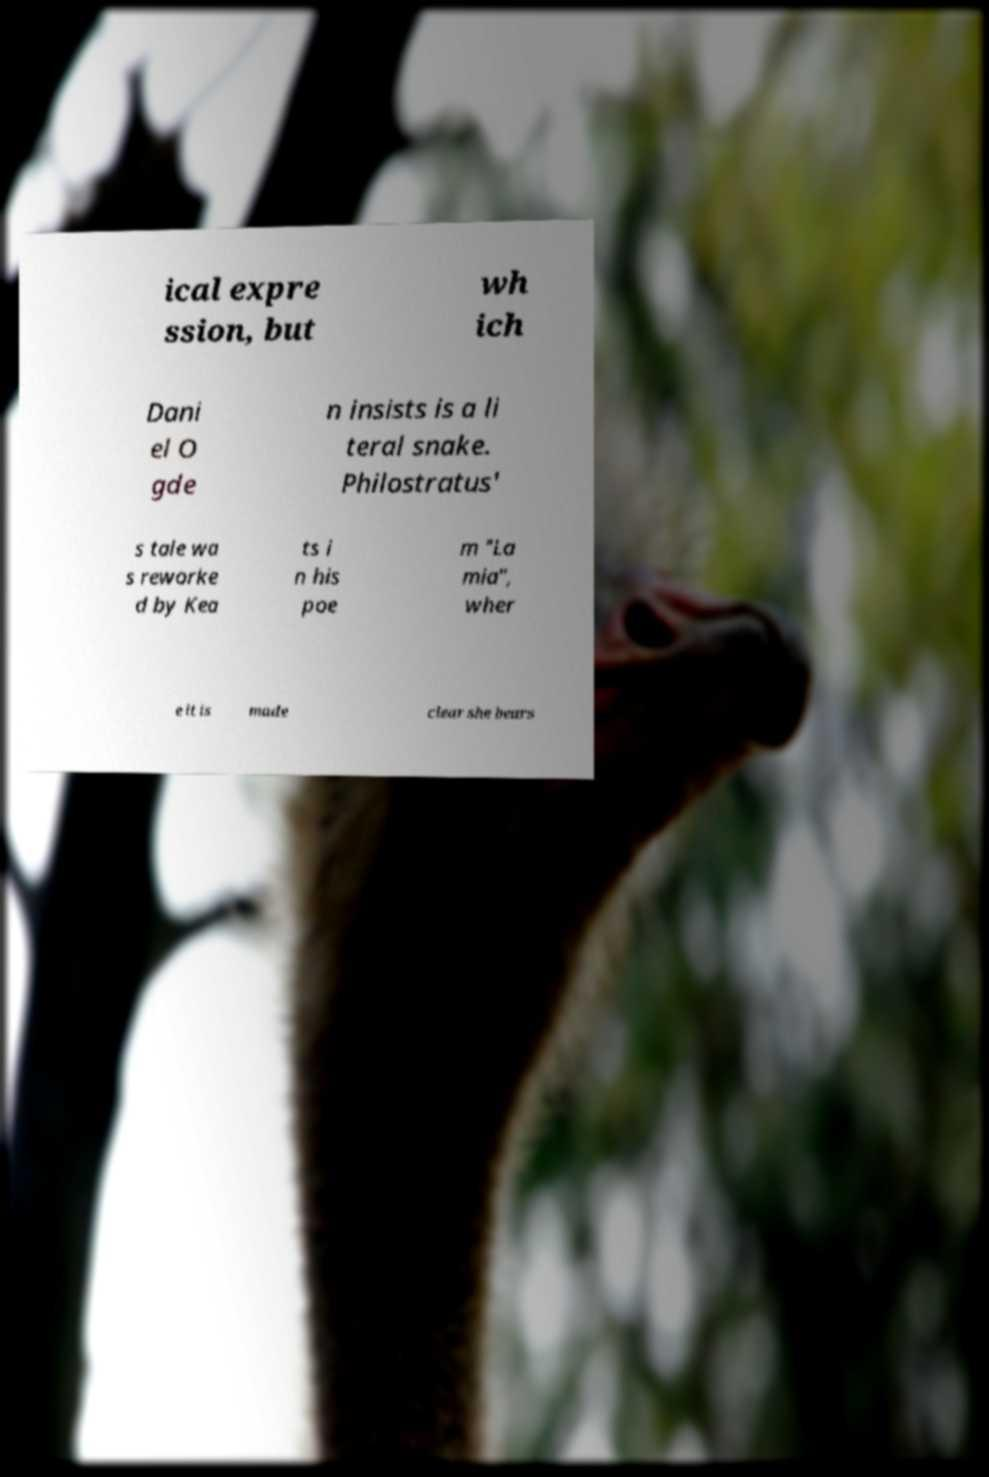I need the written content from this picture converted into text. Can you do that? ical expre ssion, but wh ich Dani el O gde n insists is a li teral snake. Philostratus' s tale wa s reworke d by Kea ts i n his poe m "La mia", wher e it is made clear she bears 